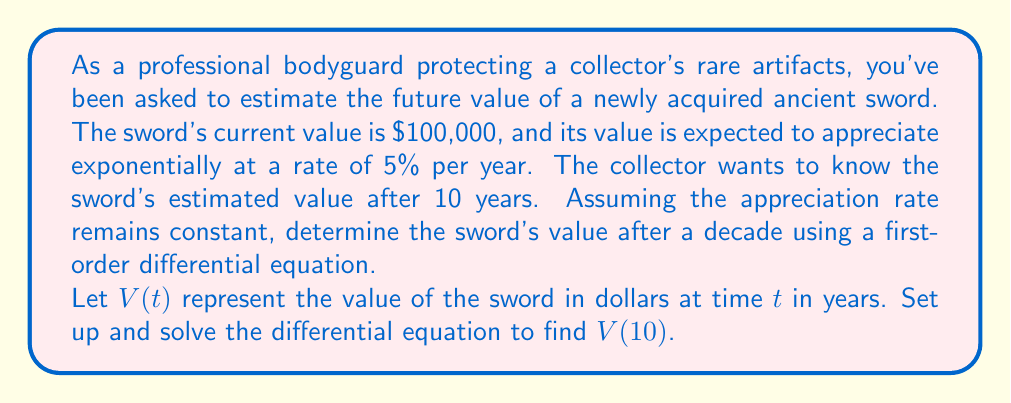Teach me how to tackle this problem. Let's approach this problem step-by-step using a first-order differential equation:

1) The rate of change of the sword's value is proportional to its current value. We can express this as:

   $$\frac{dV}{dt} = kV$$

   where $k$ is the appreciation rate constant.

2) We're given that the appreciation rate is 5% per year, so $k = 0.05$.

3) Our differential equation becomes:

   $$\frac{dV}{dt} = 0.05V$$

4) To solve this, we can separate variables:

   $$\frac{dV}{V} = 0.05dt$$

5) Integrating both sides:

   $$\int \frac{dV}{V} = \int 0.05dt$$

   $$\ln|V| = 0.05t + C$$

6) Applying the exponential function to both sides:

   $$V = e^{0.05t + C} = e^C \cdot e^{0.05t}$$

7) Let $A = e^C$. Then our general solution is:

   $$V(t) = Ae^{0.05t}$$

8) We can find $A$ using the initial condition: $V(0) = 100,000$

   $$100,000 = Ae^{0.05 \cdot 0} = A$$

9) Our particular solution is therefore:

   $$V(t) = 100,000e^{0.05t}$$

10) To find the value after 10 years, we calculate $V(10)$:

    $$V(10) = 100,000e^{0.05 \cdot 10} = 100,000e^{0.5} \approx 164,872$$
Answer: The estimated value of the sword after 10 years is approximately $164,872. 